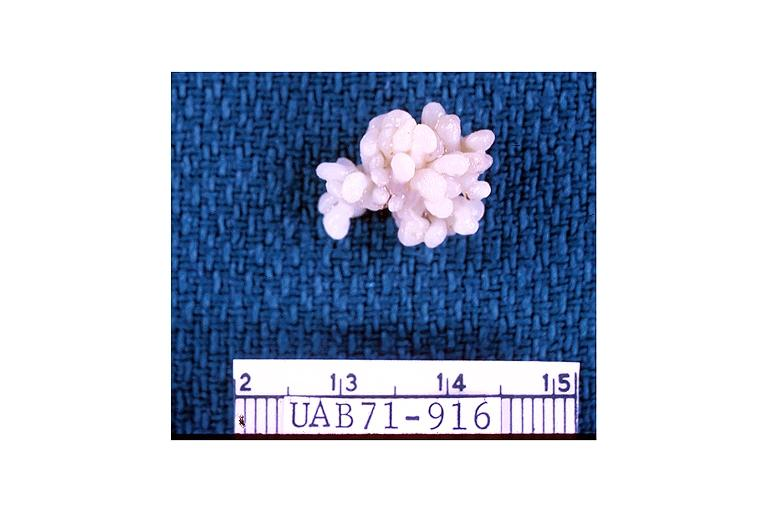s oral present?
Answer the question using a single word or phrase. Yes 